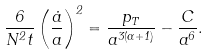Convert formula to latex. <formula><loc_0><loc_0><loc_500><loc_500>\frac { 6 } { N ^ { 2 } t } \left ( \frac { \dot { a } } { a } \right ) ^ { 2 } = \frac { p _ { T } } { a ^ { 3 ( \alpha + 1 ) } } - \frac { C } { a ^ { 6 } } .</formula> 